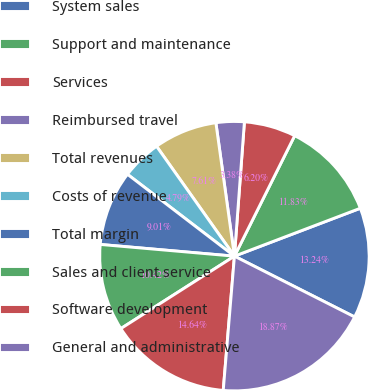Convert chart. <chart><loc_0><loc_0><loc_500><loc_500><pie_chart><fcel>System sales<fcel>Support and maintenance<fcel>Services<fcel>Reimbursed travel<fcel>Total revenues<fcel>Costs of revenue<fcel>Total margin<fcel>Sales and client service<fcel>Software development<fcel>General and administrative<nl><fcel>13.24%<fcel>11.83%<fcel>6.2%<fcel>3.38%<fcel>7.61%<fcel>4.79%<fcel>9.01%<fcel>10.42%<fcel>14.64%<fcel>18.87%<nl></chart> 